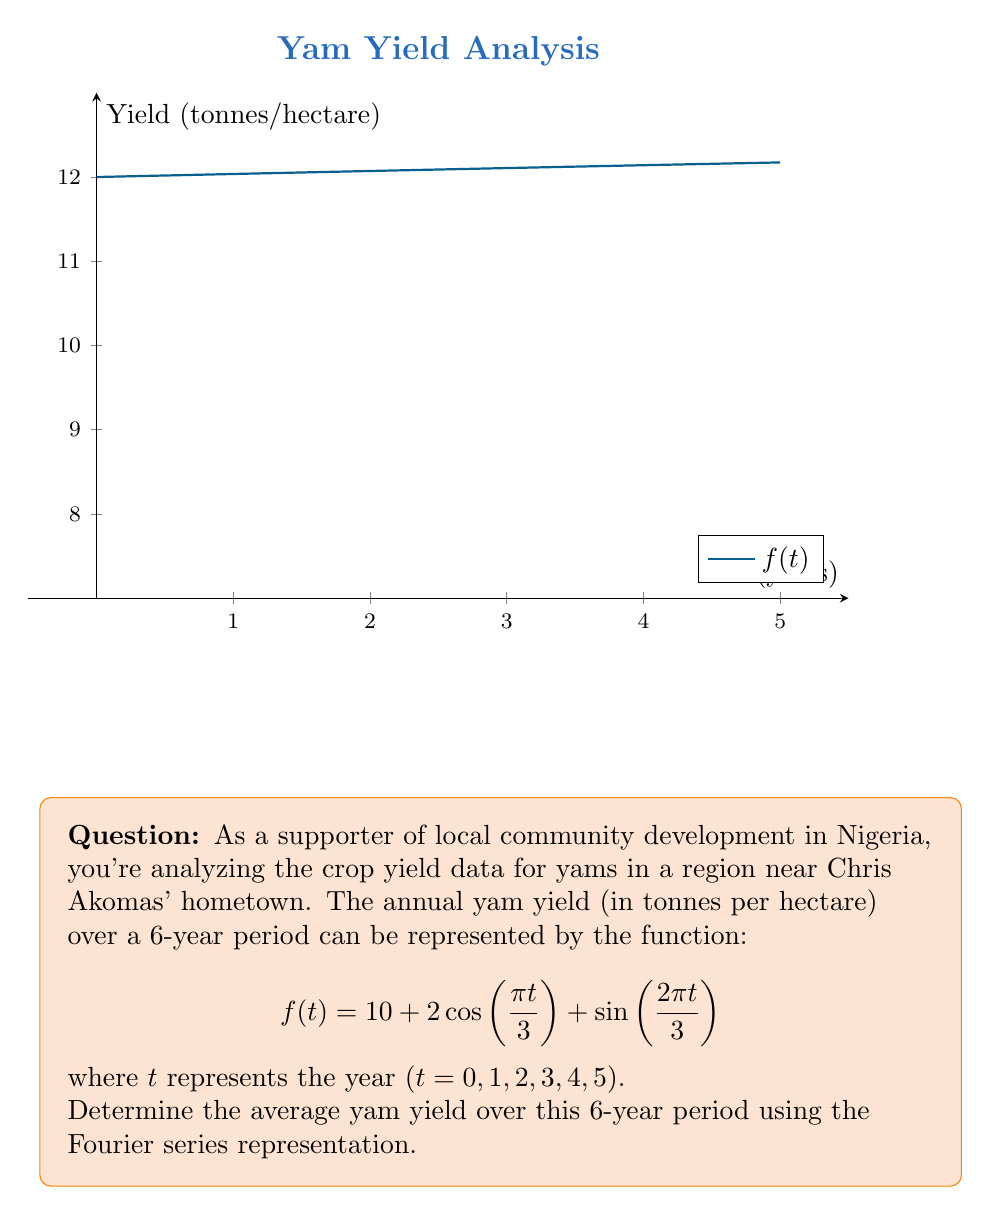Help me with this question. Let's approach this step-by-step:

1) In a Fourier series, the constant term (a₀/2) represents the average value of the function over its period. In this case, we have:

   $$f(t) = 10 + 2\cos(\frac{\pi t}{3}) + \sin(\frac{2\pi t}{3})$$

2) Comparing this to the general form of a Fourier series:

   $$f(t) = \frac{a_0}{2} + \sum_{n=1}^{\infty} \left(a_n \cos(\frac{2\pi nt}{T}) + b_n \sin(\frac{2\pi nt}{T})\right)$$

3) We can identify:
   - $\frac{a_0}{2} = 10$
   - $a_1 = 2$ (coefficient of cosine term)
   - $b_2 = 1$ (coefficient of sine term)
   - All other coefficients are zero

4) The average value of the function is represented by $\frac{a_0}{2}$, which in this case is 10.

Therefore, the average yam yield over the 6-year period is 10 tonnes per hectare.
Answer: 10 tonnes per hectare 